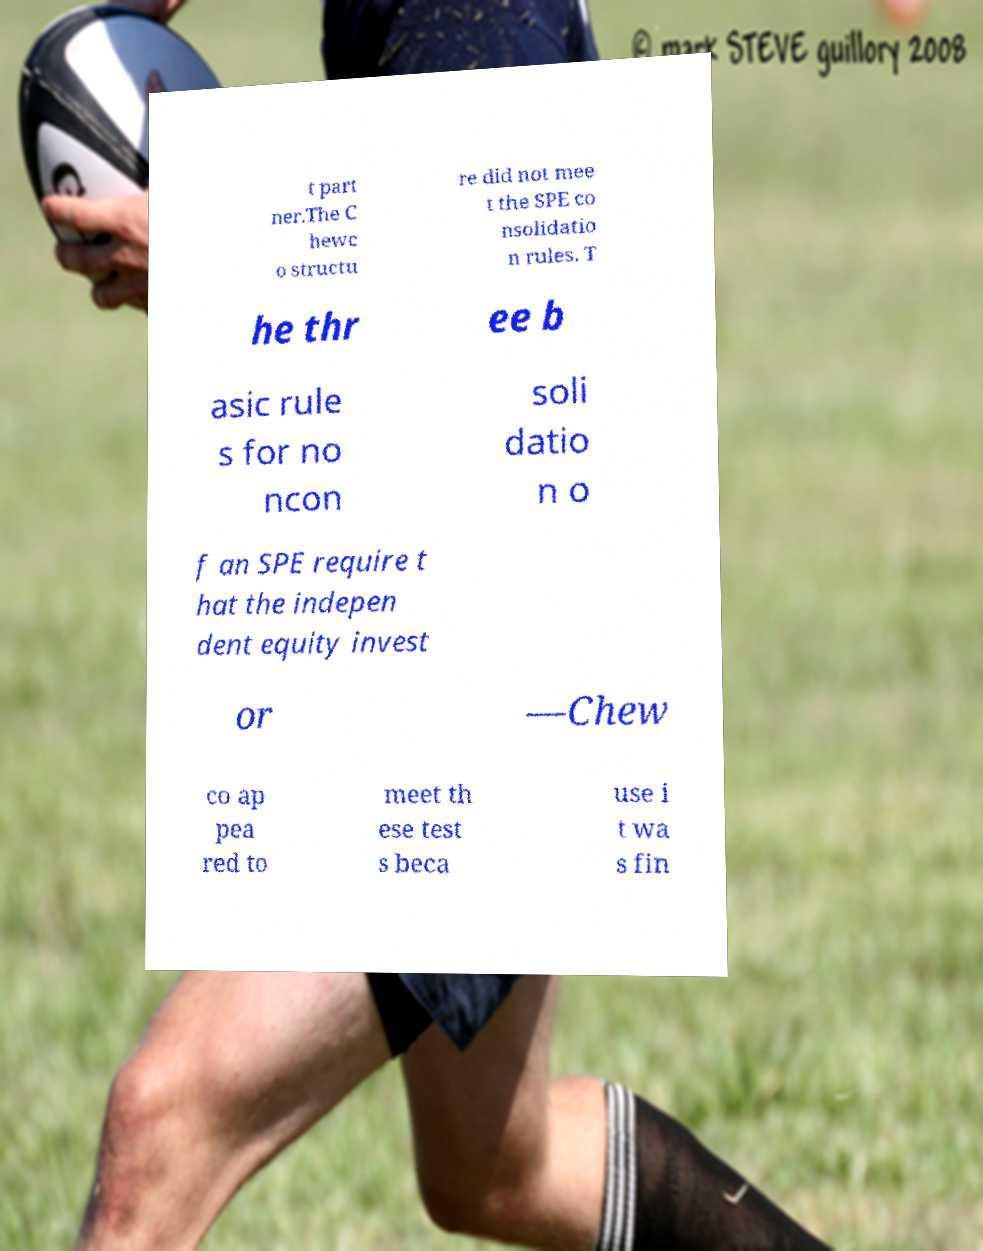Can you accurately transcribe the text from the provided image for me? t part ner.The C hewc o structu re did not mee t the SPE co nsolidatio n rules. T he thr ee b asic rule s for no ncon soli datio n o f an SPE require t hat the indepen dent equity invest or —Chew co ap pea red to meet th ese test s beca use i t wa s fin 